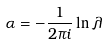<formula> <loc_0><loc_0><loc_500><loc_500>\alpha = - \frac { 1 } { 2 \pi i } \ln \lambda</formula> 